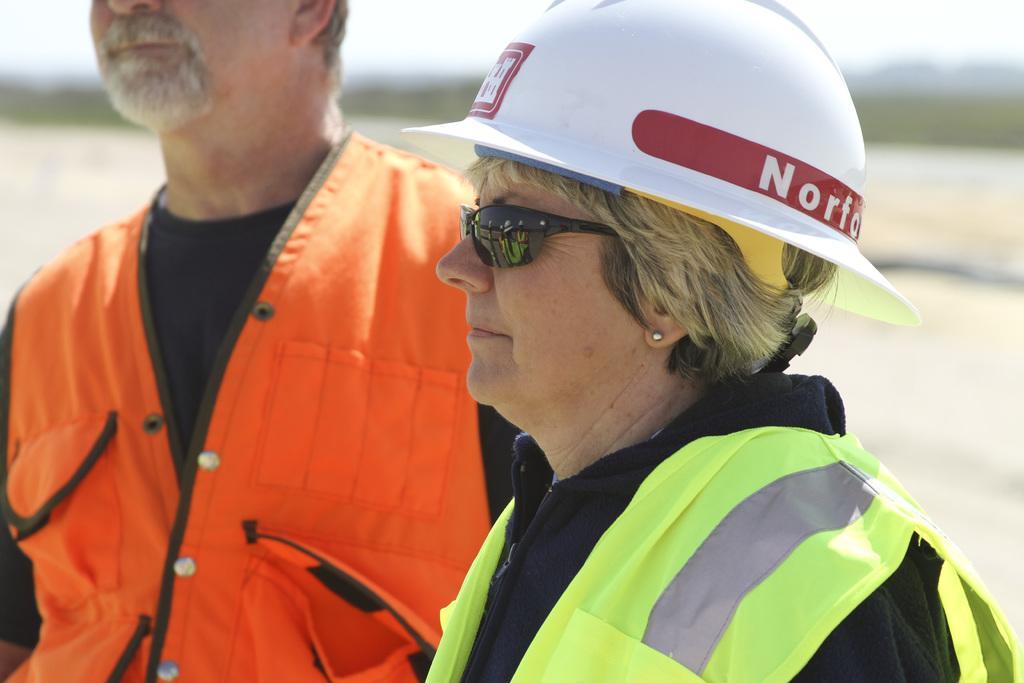Please provide a concise description of this image. In this picture there is a woman towards the right. She is wearing a green jacket, goggles and a white helmet. Beside her, towards the left, there is a man wearing a black t shirt and orange jacket. 